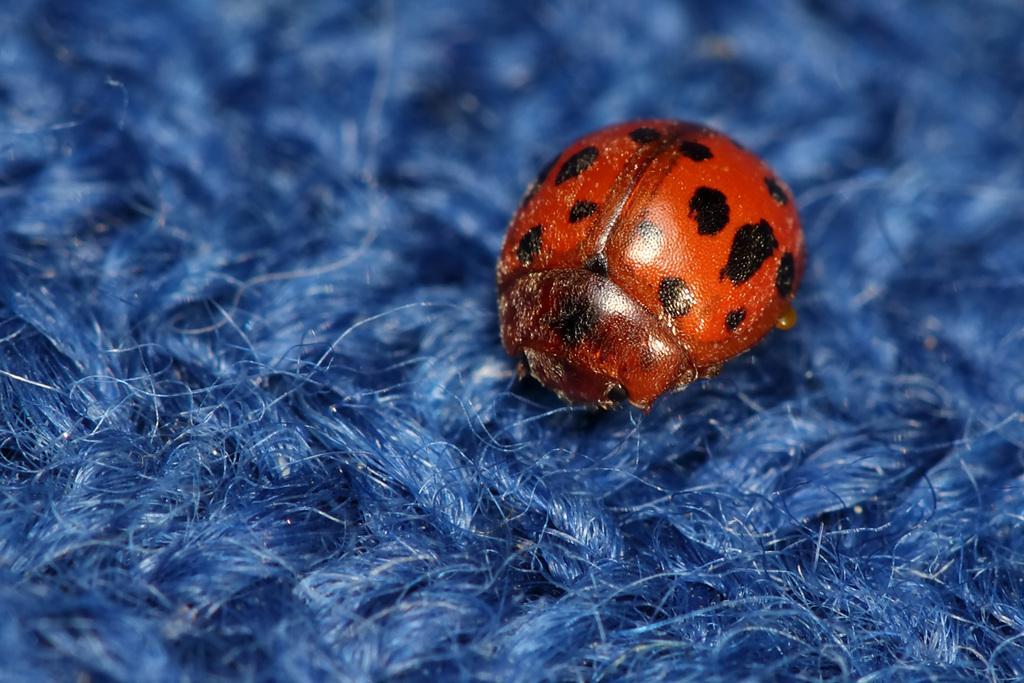Describe this image in one or two sentences. This image consists of an insect in red color. At the bottom, we can see a cloth in blue color. 